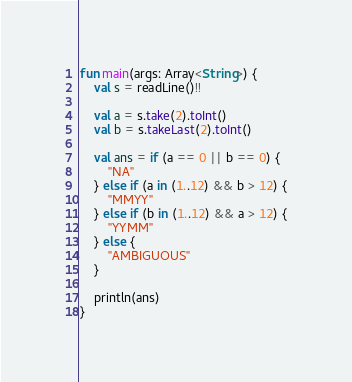Convert code to text. <code><loc_0><loc_0><loc_500><loc_500><_Kotlin_>fun main(args: Array<String>) {
    val s = readLine()!!

    val a = s.take(2).toInt()
    val b = s.takeLast(2).toInt()

    val ans = if (a == 0 || b == 0) {
        "NA"
    } else if (a in (1..12) && b > 12) {
        "MMYY"
    } else if (b in (1..12) && a > 12) {
        "YYMM"
    } else {
        "AMBIGUOUS"
    }

    println(ans)
}
</code> 